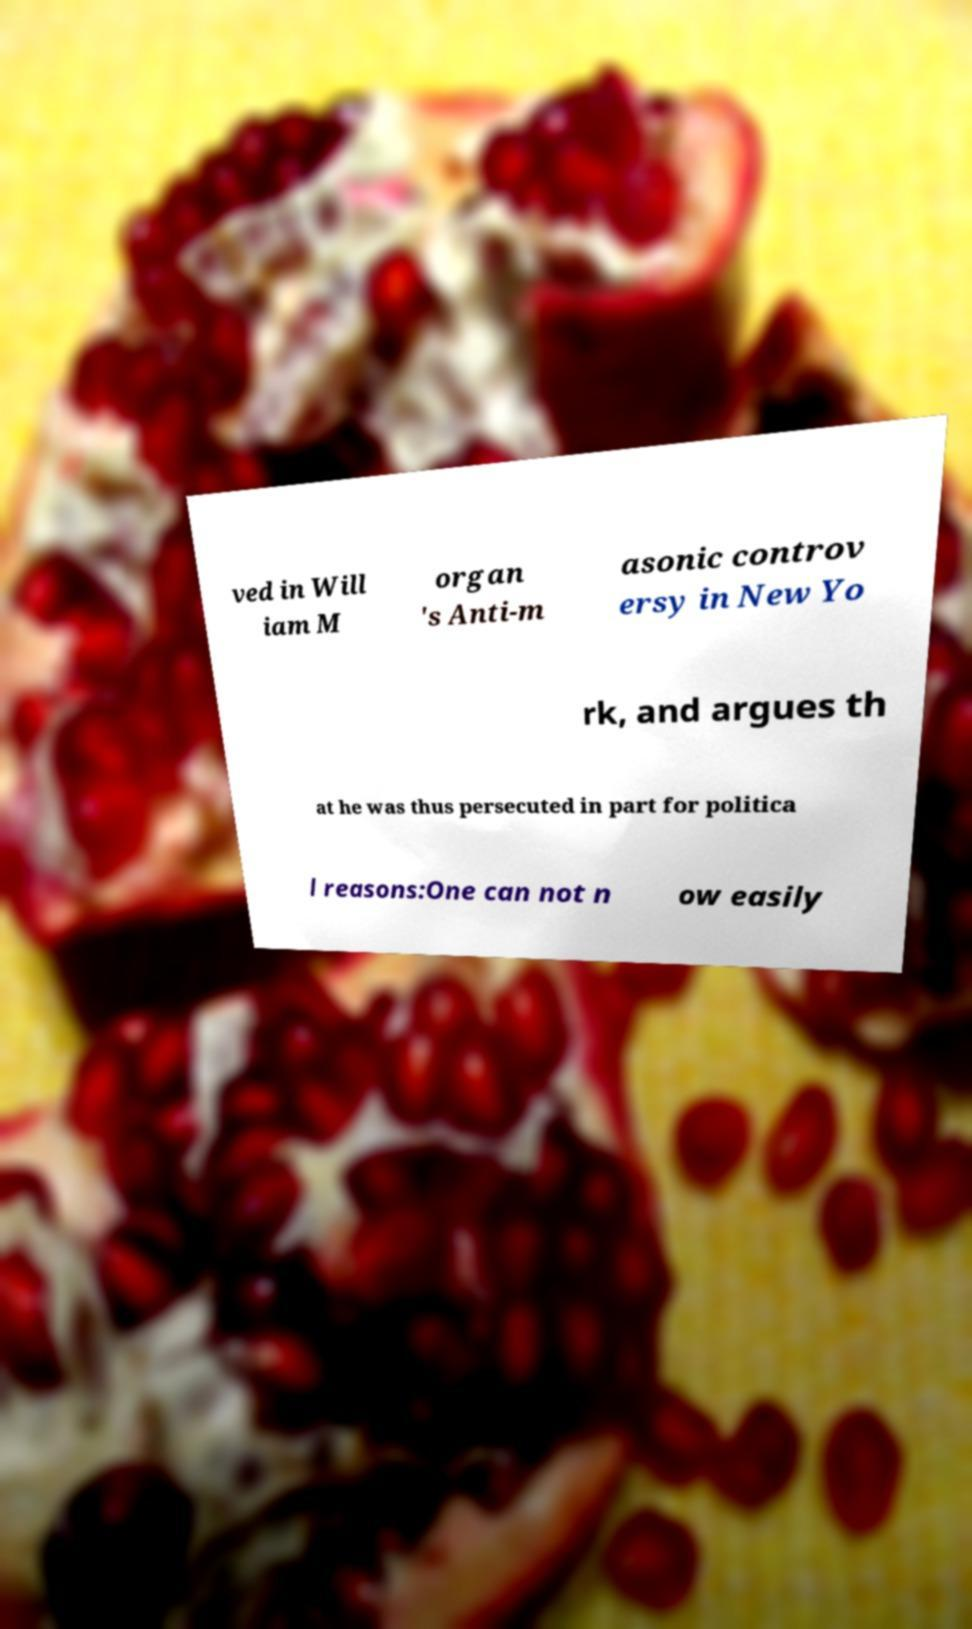Could you extract and type out the text from this image? ved in Will iam M organ 's Anti-m asonic controv ersy in New Yo rk, and argues th at he was thus persecuted in part for politica l reasons:One can not n ow easily 